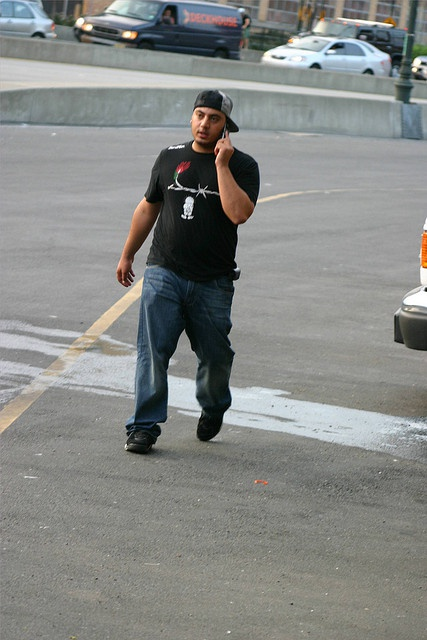Describe the objects in this image and their specific colors. I can see people in lavender, black, darkgray, gray, and brown tones, truck in lavender, black, gray, and darkgray tones, car in lavender, white, darkgray, and lightblue tones, truck in lavender, darkgray, gray, black, and ivory tones, and car in lavender, black, white, darkgray, and gray tones in this image. 